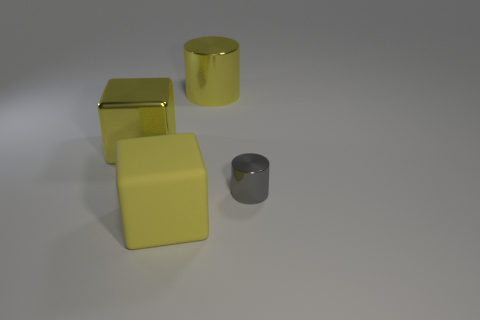Are there any other things that have the same size as the gray shiny cylinder?
Give a very brief answer. No. What shape is the large object that is the same material as the large yellow cylinder?
Make the answer very short. Cube. There is a metallic object that is the same size as the yellow shiny cylinder; what is its color?
Offer a very short reply. Yellow. Do the metallic object in front of the yellow metallic block and the big metallic cylinder have the same size?
Keep it short and to the point. No. Does the shiny block have the same color as the large matte object?
Provide a succinct answer. Yes. What number of yellow shiny cubes are there?
Give a very brief answer. 1. What number of cylinders are yellow metal things or rubber objects?
Keep it short and to the point. 1. There is a large shiny object in front of the big yellow cylinder; how many big objects are behind it?
Your response must be concise. 1. Is the gray cylinder made of the same material as the big cylinder?
Provide a short and direct response. Yes. There is a cylinder that is the same color as the matte cube; what is its size?
Offer a very short reply. Large. 